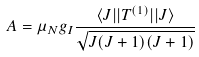<formula> <loc_0><loc_0><loc_500><loc_500>A = \mu _ { N } g _ { I } \frac { \langle J | | T ^ { ( 1 ) } | | J \rangle } { \sqrt { J ( J + 1 ) ( J + 1 ) } }</formula> 